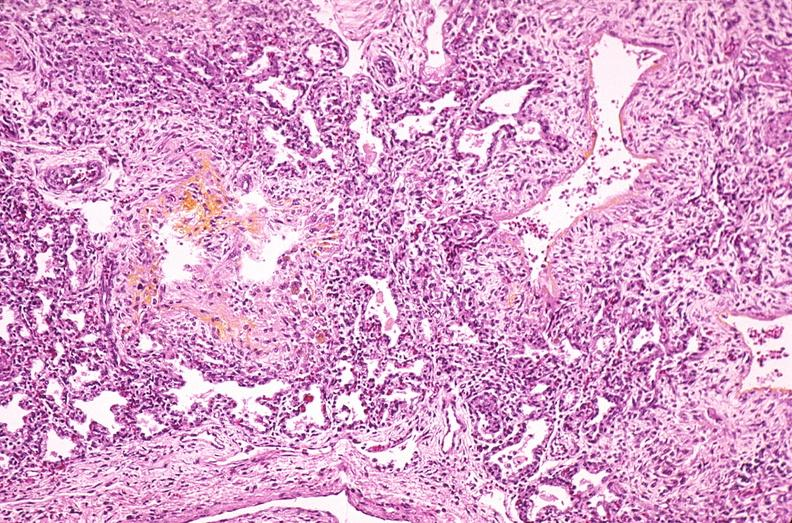s respiratory present?
Answer the question using a single word or phrase. Yes 